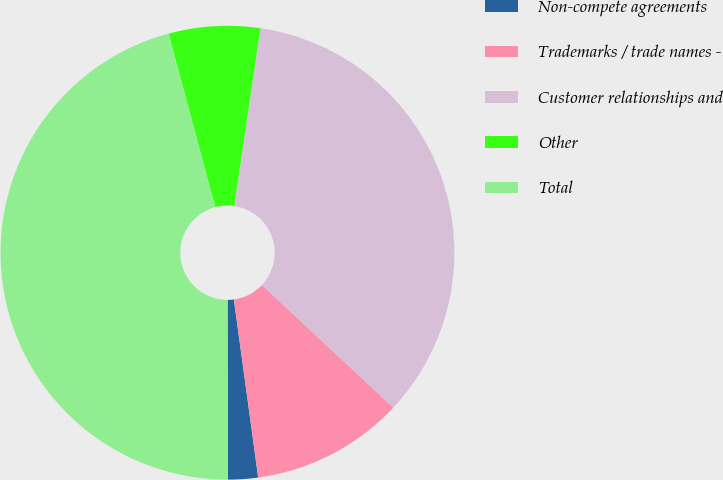<chart> <loc_0><loc_0><loc_500><loc_500><pie_chart><fcel>Non-compete agreements<fcel>Trademarks / trade names -<fcel>Customer relationships and<fcel>Other<fcel>Total<nl><fcel>2.13%<fcel>10.88%<fcel>34.64%<fcel>6.5%<fcel>45.85%<nl></chart> 